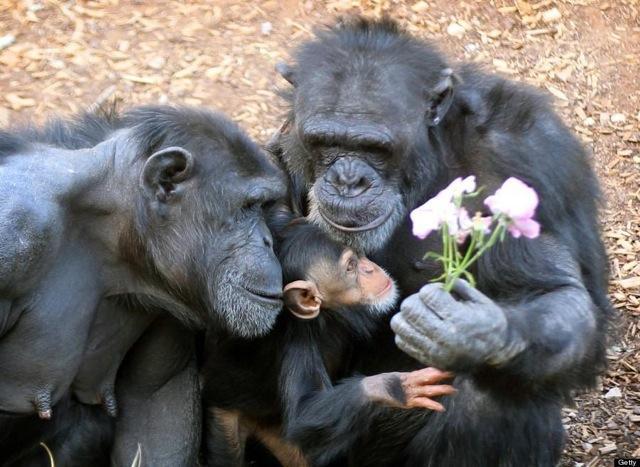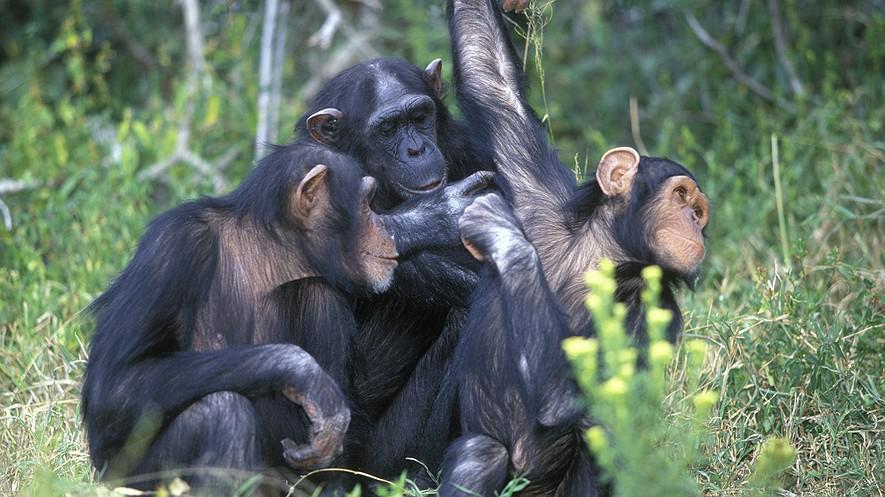The first image is the image on the left, the second image is the image on the right. Assess this claim about the two images: "One chimp has a wide open mouth showing its front row of teeth.". Correct or not? Answer yes or no. No. The first image is the image on the left, the second image is the image on the right. Analyze the images presented: Is the assertion "One of the animals in the image on the left has its teeth exposed." valid? Answer yes or no. No. 